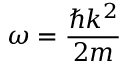<formula> <loc_0><loc_0><loc_500><loc_500>\omega = { \frac { \hbar { k } ^ { 2 } } { 2 m } }</formula> 